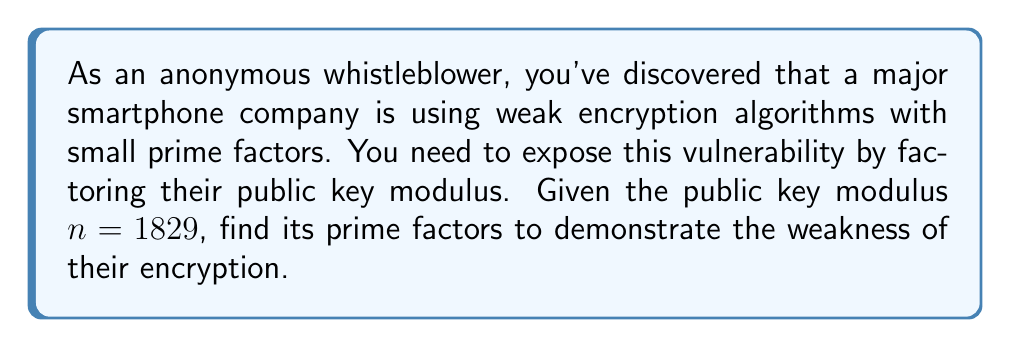Provide a solution to this math problem. To find the prime factors of 1829, we'll use the trial division method:

1) First, let's check if any small prime numbers divide 1829 evenly:

   $1829 \div 2 = 914.5$ (not divisible)
   $1829 \div 3 = 609.66...$ (not divisible)
   $1829 \div 5 = 365.8$ (not divisible)
   $1829 \div 7 = 261.28...$ (not divisible)

2) We can stop at 7 because $\sqrt{1829} \approx 42.77$, and we only need to check up to the square root.

3) Since no small primes divide 1829, let's try larger numbers:

   $1829 \div 41 = 44.60...$ (not divisible)
   $1829 \div 42 = 43.54...$ (not divisible)
   $1829 \div 43 = 42.53...$ (not divisible)

4) When we try 43, we get:

   $1829 \div 43 = 42.53...$

5) Let's check if 43 is actually a factor:

   $1829 = 43 \times 42 + 23$

6) Indeed, 43 is a factor. Now we need to find the other factor:

   $1829 \div 43 = 42.53...$

7) The other factor must be 1829 ÷ 43 = 43 (rounded up from 42.53...)

8) We can verify: $43 \times 43 = 1849$

Therefore, the prime factorization of 1829 is $43 \times 43$.
Answer: The prime factors of 1829 are $43$ and $43$. In other words, $1829 = 43^2$. 